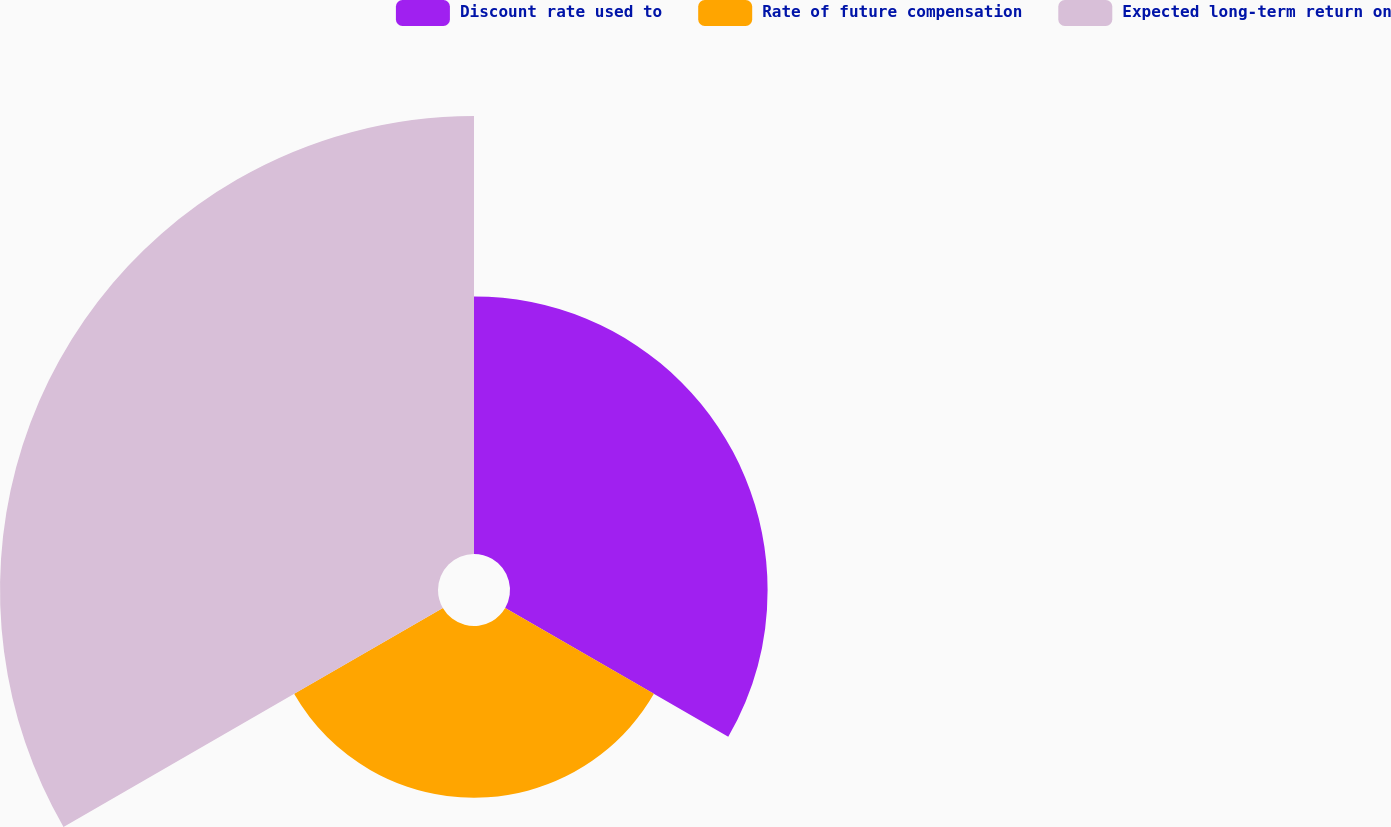Convert chart to OTSL. <chart><loc_0><loc_0><loc_500><loc_500><pie_chart><fcel>Discount rate used to<fcel>Rate of future compensation<fcel>Expected long-term return on<nl><fcel>29.7%<fcel>19.8%<fcel>50.5%<nl></chart> 